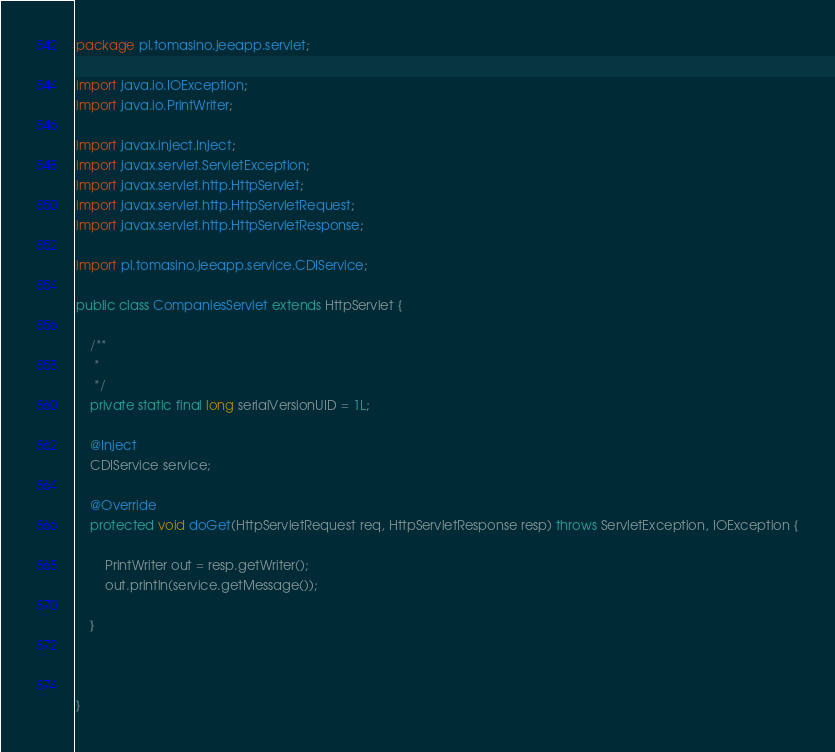Convert code to text. <code><loc_0><loc_0><loc_500><loc_500><_Java_>package pl.tomasino.jeeapp.servlet;

import java.io.IOException;
import java.io.PrintWriter;

import javax.inject.Inject;
import javax.servlet.ServletException;
import javax.servlet.http.HttpServlet;
import javax.servlet.http.HttpServletRequest;
import javax.servlet.http.HttpServletResponse;

import pl.tomasino.jeeapp.service.CDIService;

public class CompaniesServlet extends HttpServlet {

	/**
	 * 
	 */
	private static final long serialVersionUID = 1L;

	@Inject
	CDIService service;

	@Override
	protected void doGet(HttpServletRequest req, HttpServletResponse resp) throws ServletException, IOException {

		PrintWriter out = resp.getWriter();
		out.println(service.getMessage());

	}

	

}
</code> 